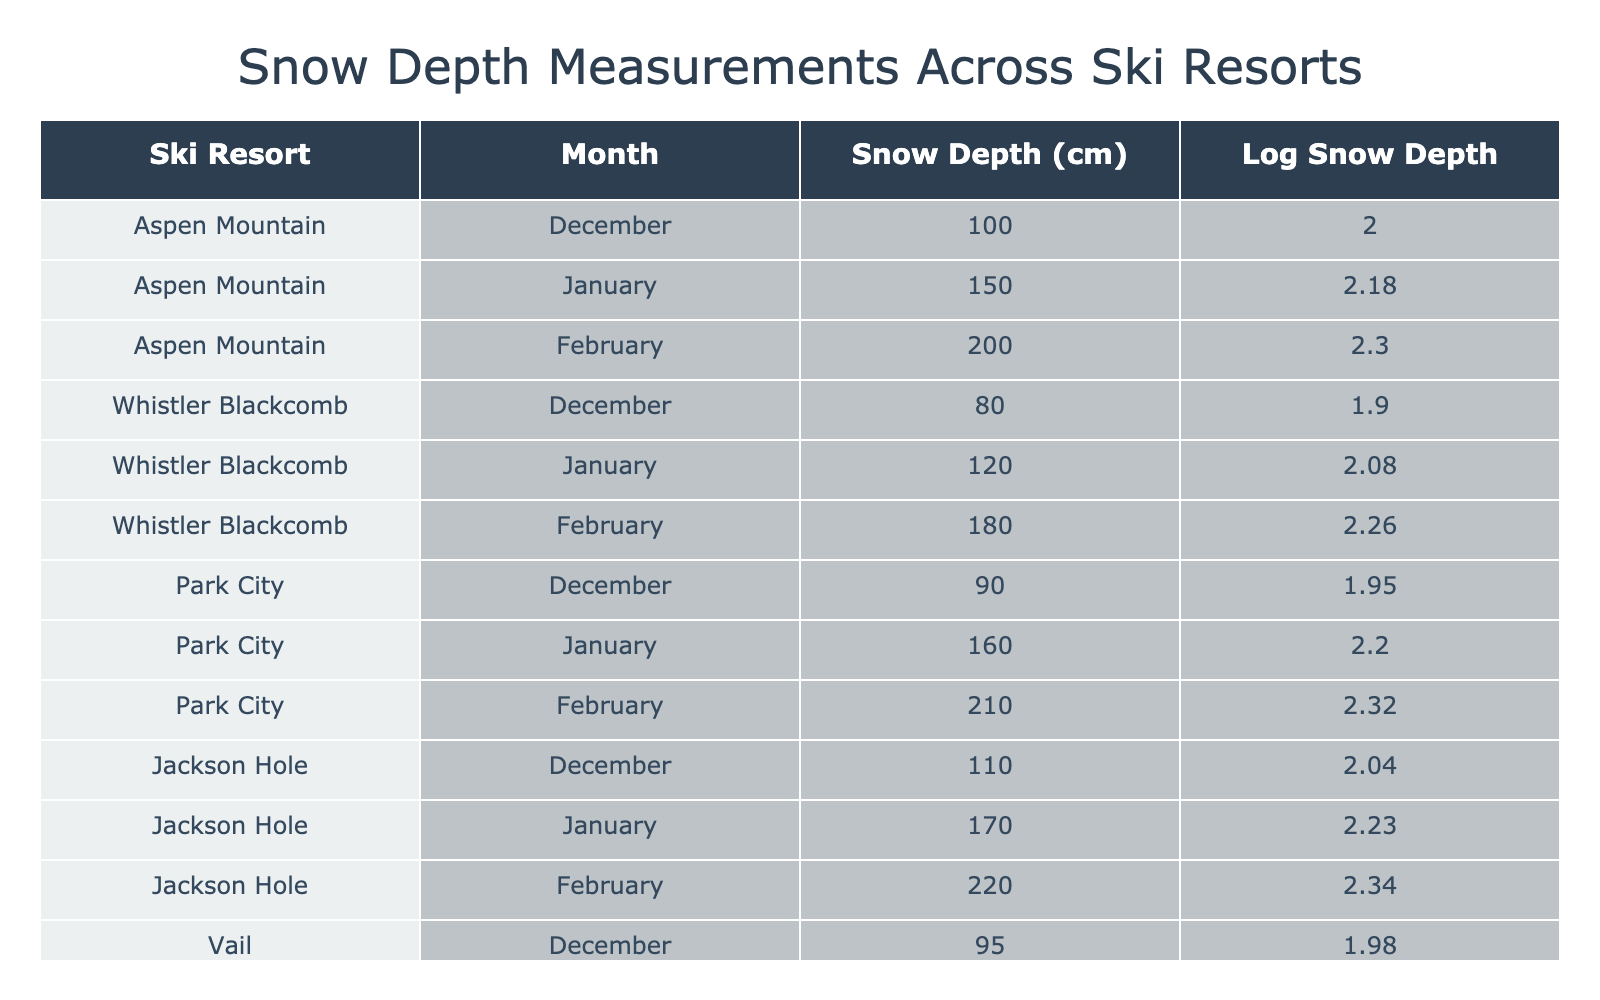What is the snow depth in Jackson Hole for February? In the table, we look for the row corresponding to Jackson Hole in the month of February. The snow depth listed for that specific combination is 220 cm.
Answer: 220 cm Which ski resort had the highest snow depth in January? We compare the snow depths for each resort in January. Aspen Mountain has 150 cm, Whistler Blackcomb has 120 cm, Park City has 160 cm, Jackson Hole has 170 cm, and Vail has 140 cm. The highest value is 170 cm at Jackson Hole.
Answer: Jackson Hole What is the average snow depth across all ski resorts for December? We collect the December values for snow depth: 100 cm (Aspen Mountain), 80 cm (Whistler Blackcomb), 90 cm (Park City), 110 cm (Jackson Hole), and 95 cm (Vail). The sum is 100 + 80 + 90 + 110 + 95 = 475 cm. Since there are 5 resorts, we calculate the average: 475 / 5 = 95 cm.
Answer: 95 cm Is the snow depth in February for any resort more than 200 cm? We examine the February values: Aspen Mountain has 200 cm, Whistler Blackcomb has 180 cm, Park City has 210 cm, Jackson Hole has 220 cm, and Vail has 205 cm. Both Park City and Jackson Hole exceed 200 cm. Therefore, the answer is yes.
Answer: Yes What are the logarithmic values of snow depth for Whistler Blackcomb in January and February? We refer to the table for Whistler Blackcomb. In January, the snow depth is 120 cm, and its logarithmic value is approximately 2.08. In February, the snow depth is 180 cm, with a logarithmic value of approximately 2.25.
Answer: January: 2.08, February: 2.25 Which month had the least snow depth for Park City? We check the snow depths for Park City across all months: December (90 cm), January (160 cm), and February (210 cm). The minimum value is 90 cm in December.
Answer: December How much did snow depth increase from December to February in Aspen Mountain? For Aspen Mountain, the snow depth in December is 100 cm, and in February it is 200 cm. The increase is calculated as 200 - 100 = 100 cm.
Answer: 100 cm Did Vail have a higher snow depth in February compared to December? We compare the snow depth in February (205 cm) and December (95 cm) for Vail. Since 205 cm is greater than 95 cm, the answer is yes.
Answer: Yes What is the total snow depth across all ski resorts for January? We sum the January snow depths: 150 cm (Aspen Mountain), 120 cm (Whistler Blackcomb), 160 cm (Park City), 170 cm (Jackson Hole), and 140 cm (Vail). The total is 150 + 120 + 160 + 170 + 140 = 840 cm.
Answer: 840 cm 